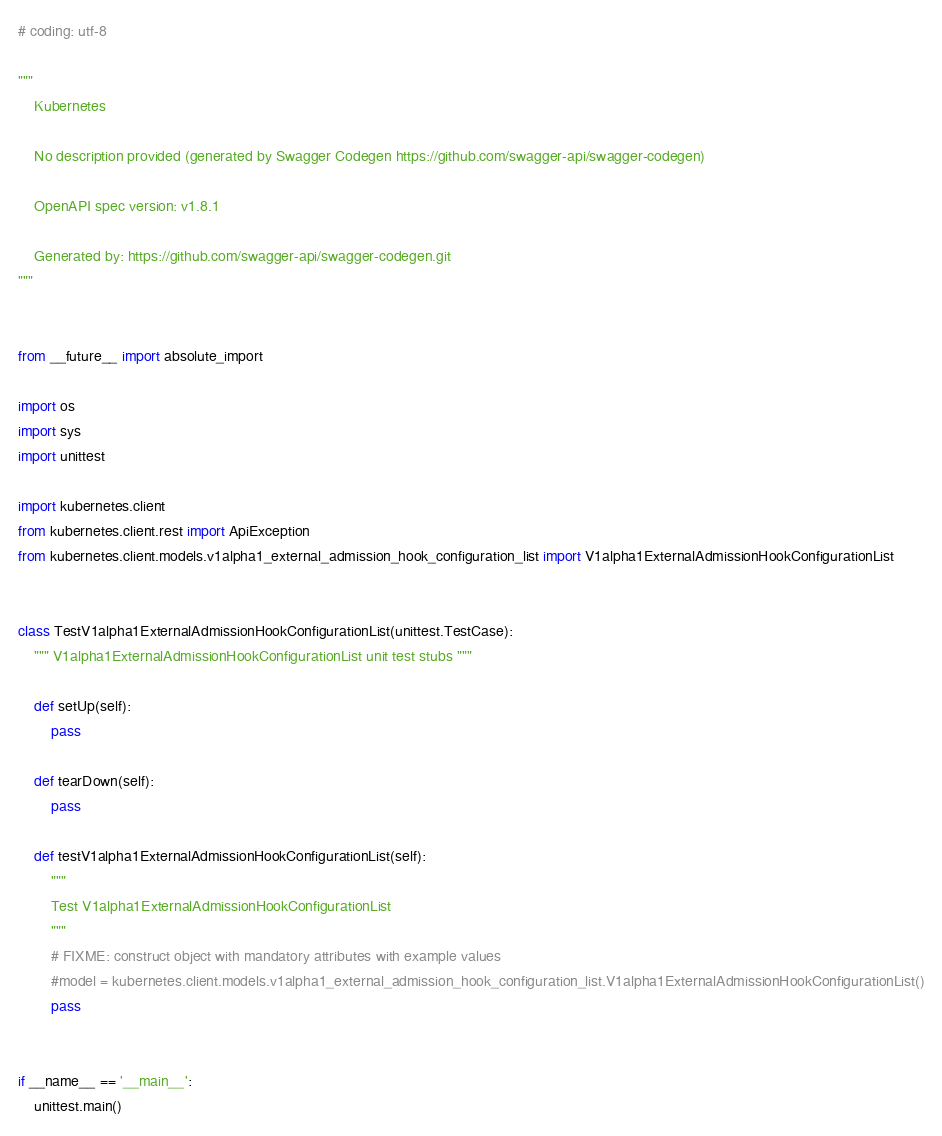Convert code to text. <code><loc_0><loc_0><loc_500><loc_500><_Python_># coding: utf-8

"""
    Kubernetes

    No description provided (generated by Swagger Codegen https://github.com/swagger-api/swagger-codegen)

    OpenAPI spec version: v1.8.1
    
    Generated by: https://github.com/swagger-api/swagger-codegen.git
"""


from __future__ import absolute_import

import os
import sys
import unittest

import kubernetes.client
from kubernetes.client.rest import ApiException
from kubernetes.client.models.v1alpha1_external_admission_hook_configuration_list import V1alpha1ExternalAdmissionHookConfigurationList


class TestV1alpha1ExternalAdmissionHookConfigurationList(unittest.TestCase):
    """ V1alpha1ExternalAdmissionHookConfigurationList unit test stubs """

    def setUp(self):
        pass

    def tearDown(self):
        pass

    def testV1alpha1ExternalAdmissionHookConfigurationList(self):
        """
        Test V1alpha1ExternalAdmissionHookConfigurationList
        """
        # FIXME: construct object with mandatory attributes with example values
        #model = kubernetes.client.models.v1alpha1_external_admission_hook_configuration_list.V1alpha1ExternalAdmissionHookConfigurationList()
        pass


if __name__ == '__main__':
    unittest.main()
</code> 